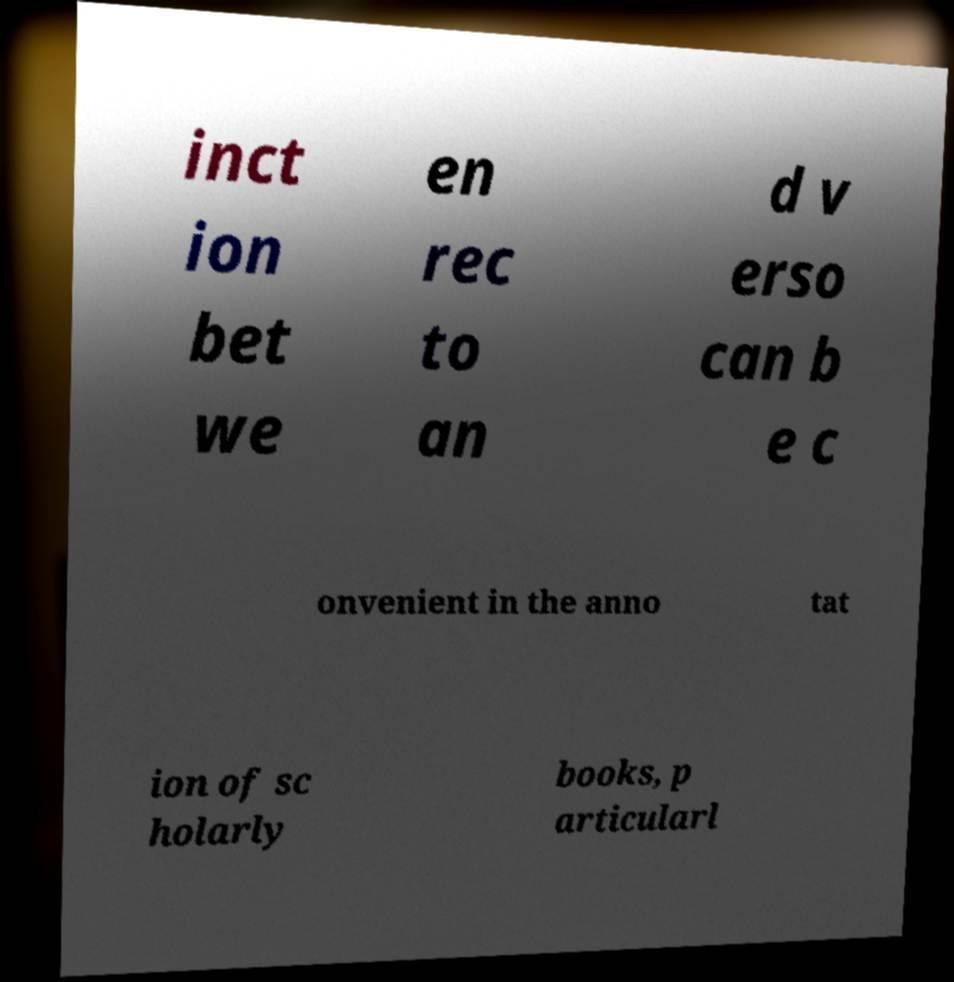I need the written content from this picture converted into text. Can you do that? inct ion bet we en rec to an d v erso can b e c onvenient in the anno tat ion of sc holarly books, p articularl 